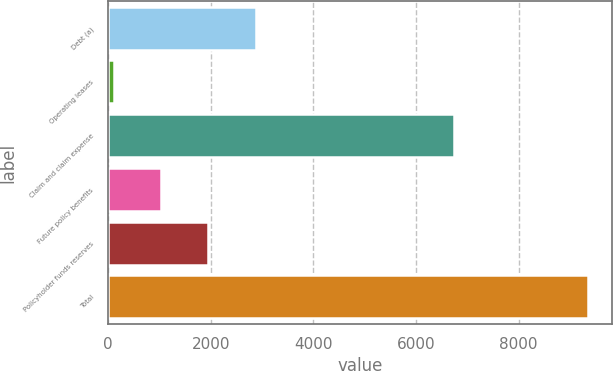Convert chart to OTSL. <chart><loc_0><loc_0><loc_500><loc_500><bar_chart><fcel>Debt (a)<fcel>Operating leases<fcel>Claim and claim expense<fcel>Future policy benefits<fcel>Policyholder funds reserves<fcel>Total<nl><fcel>2874.7<fcel>103<fcel>6733<fcel>1026.9<fcel>1950.8<fcel>9342<nl></chart> 